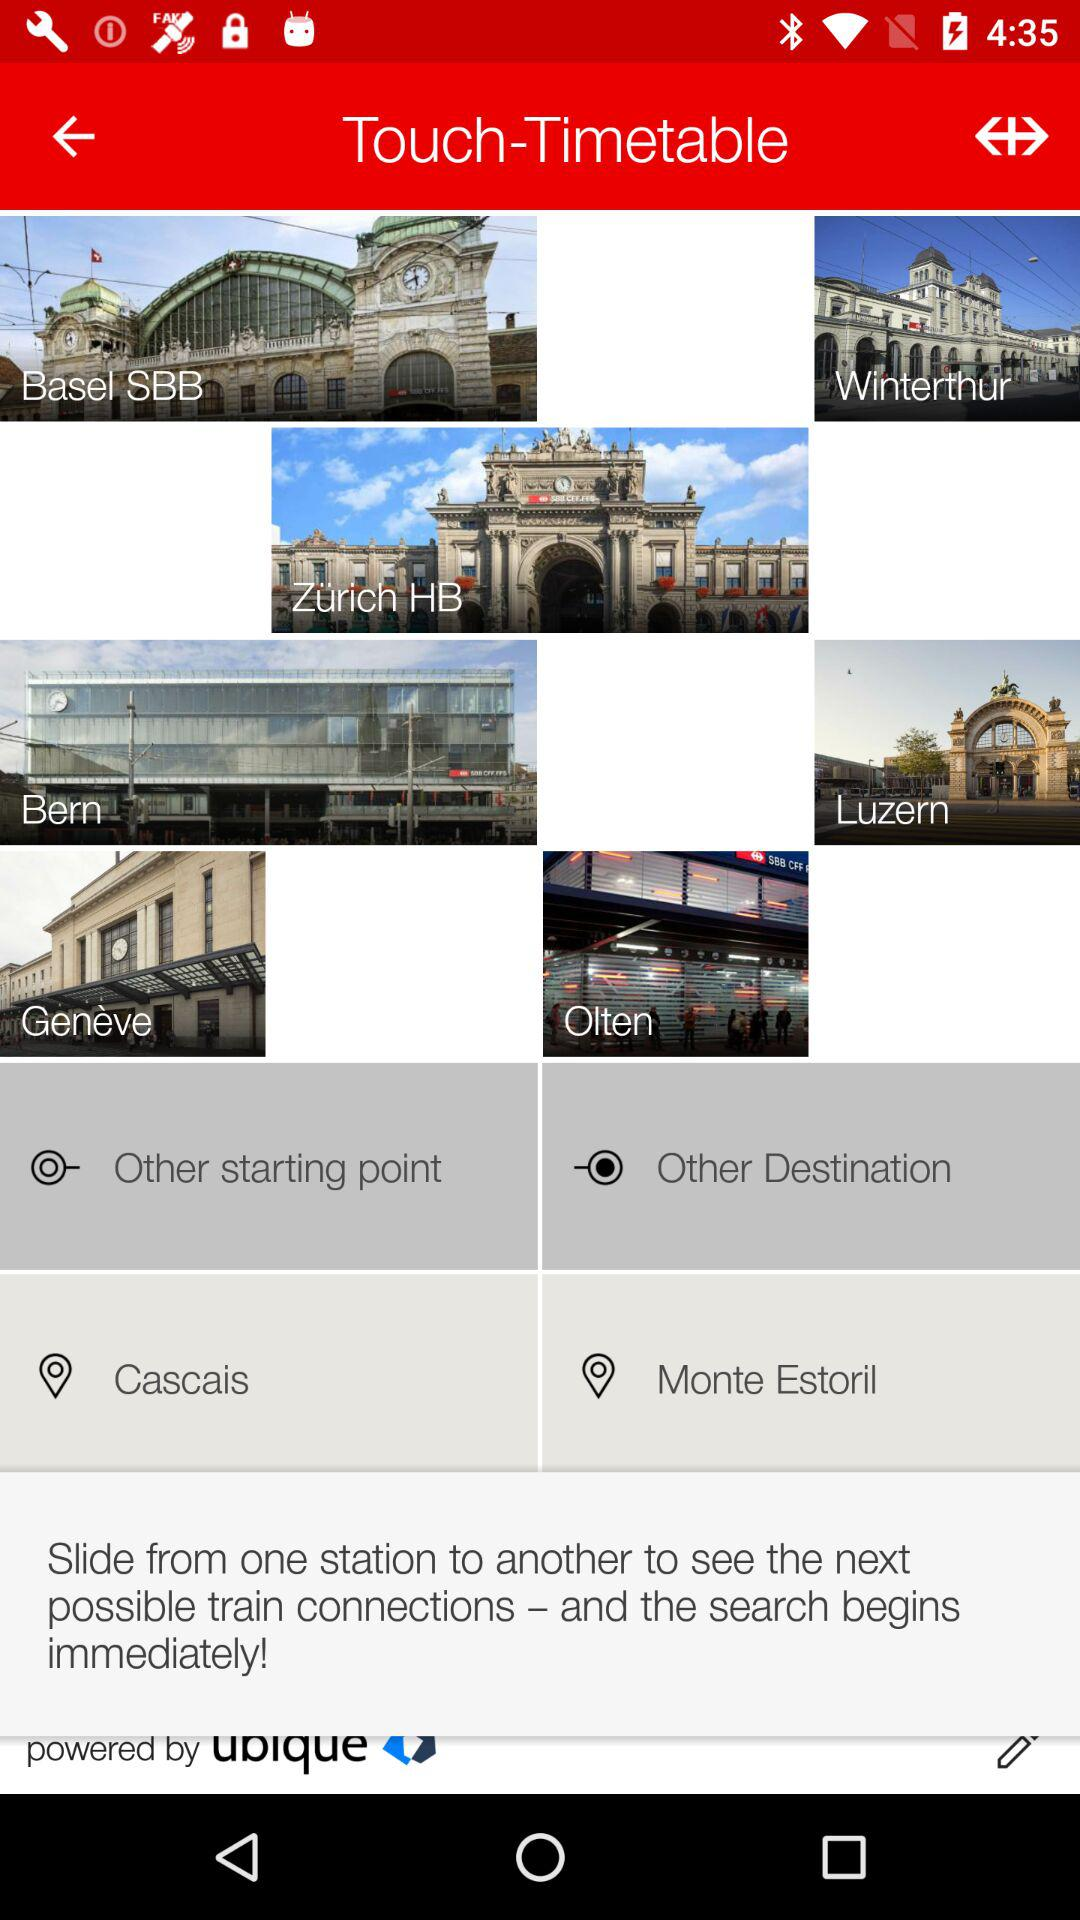What is the name of the other starting point? The name of the other starting point is Cascais. 